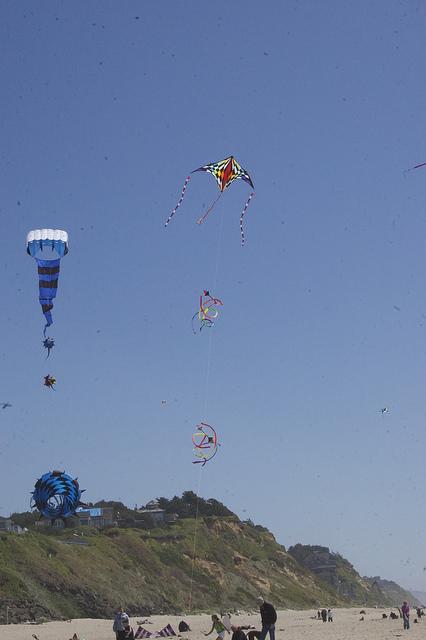What are these people doing?
Be succinct. Flying kites. How many hot air balloons can be found in the picture?
Quick response, please. 0. Where is this photo taken?
Be succinct. Beach. Are all the kites the same size?
Concise answer only. No. What is in the sky?
Concise answer only. Kites. Are the kites flying over water?
Quick response, please. No. Where is the blue umbrella?
Give a very brief answer. Beach. 